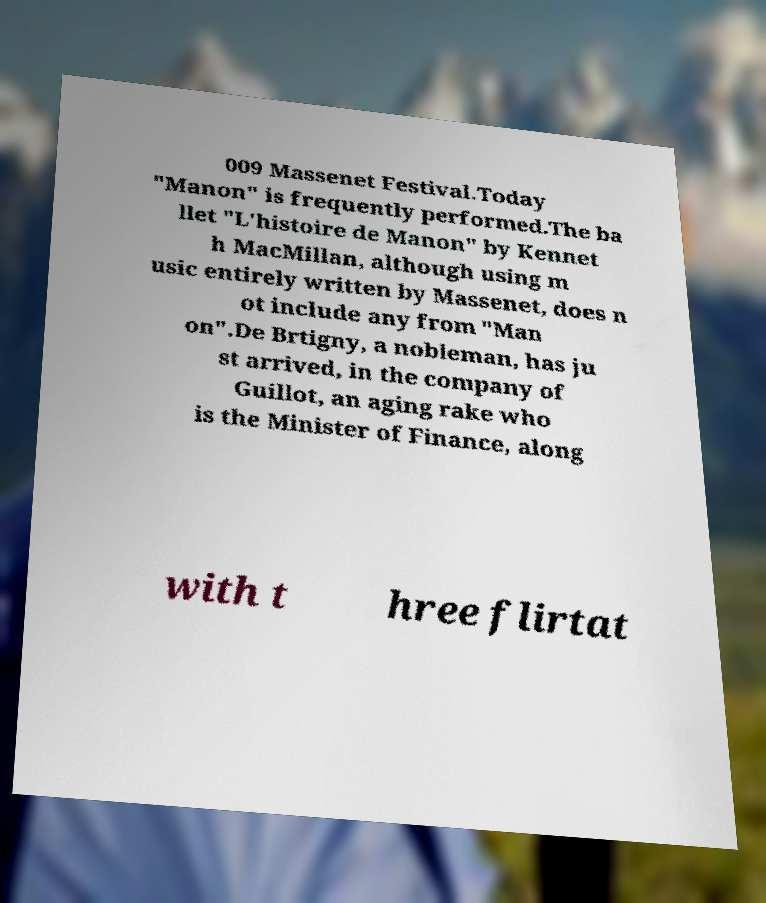Please identify and transcribe the text found in this image. 009 Massenet Festival.Today "Manon" is frequently performed.The ba llet "L'histoire de Manon" by Kennet h MacMillan, although using m usic entirely written by Massenet, does n ot include any from "Man on".De Brtigny, a nobleman, has ju st arrived, in the company of Guillot, an aging rake who is the Minister of Finance, along with t hree flirtat 